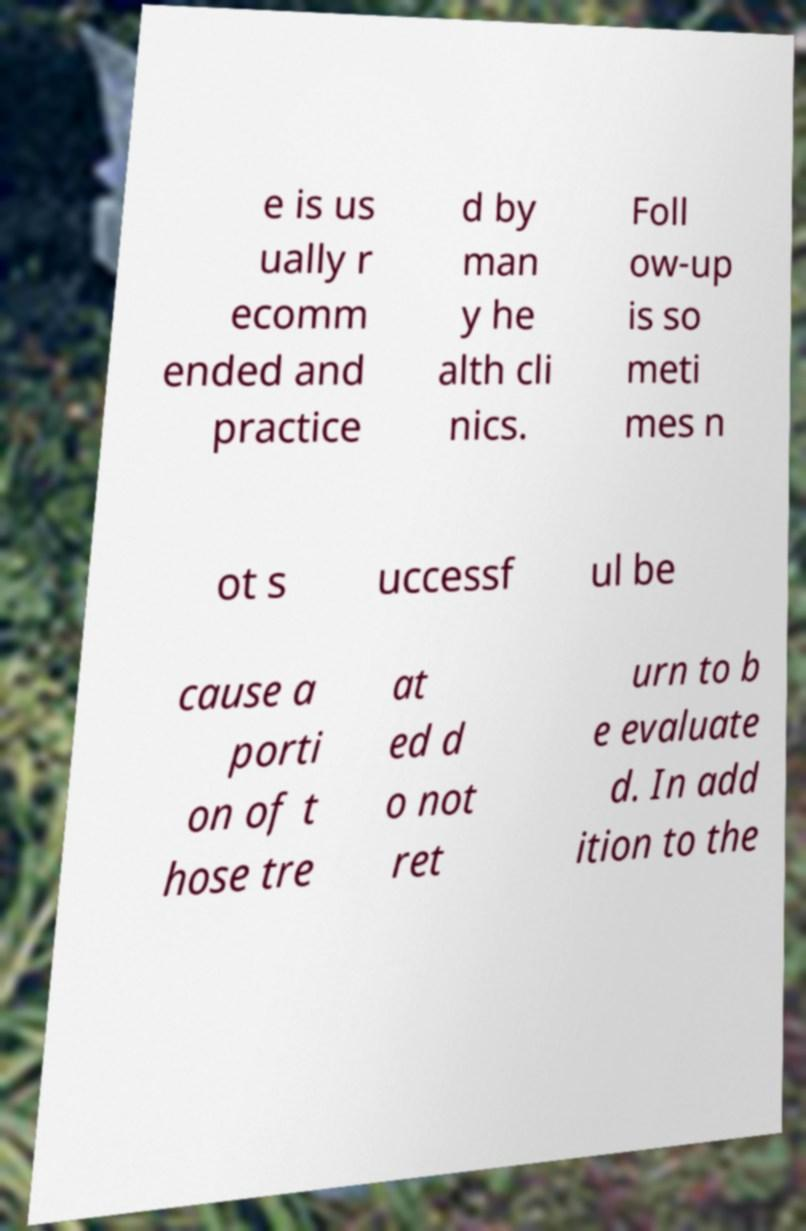There's text embedded in this image that I need extracted. Can you transcribe it verbatim? e is us ually r ecomm ended and practice d by man y he alth cli nics. Foll ow-up is so meti mes n ot s uccessf ul be cause a porti on of t hose tre at ed d o not ret urn to b e evaluate d. In add ition to the 